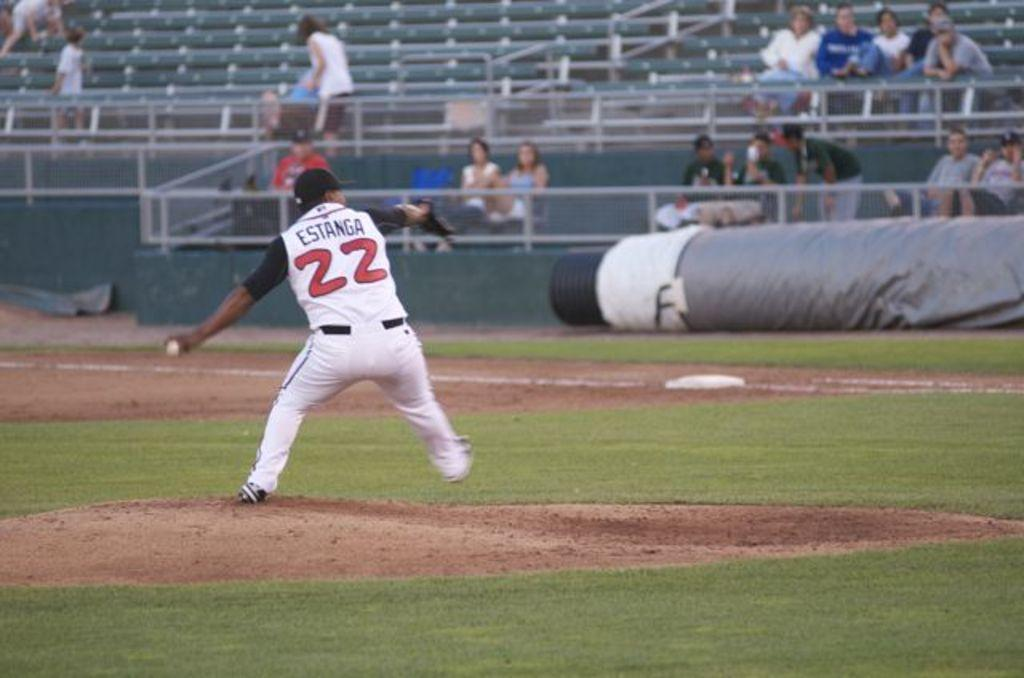<image>
Share a concise interpretation of the image provided. a person in a baseball jersey with the number 22 on it 